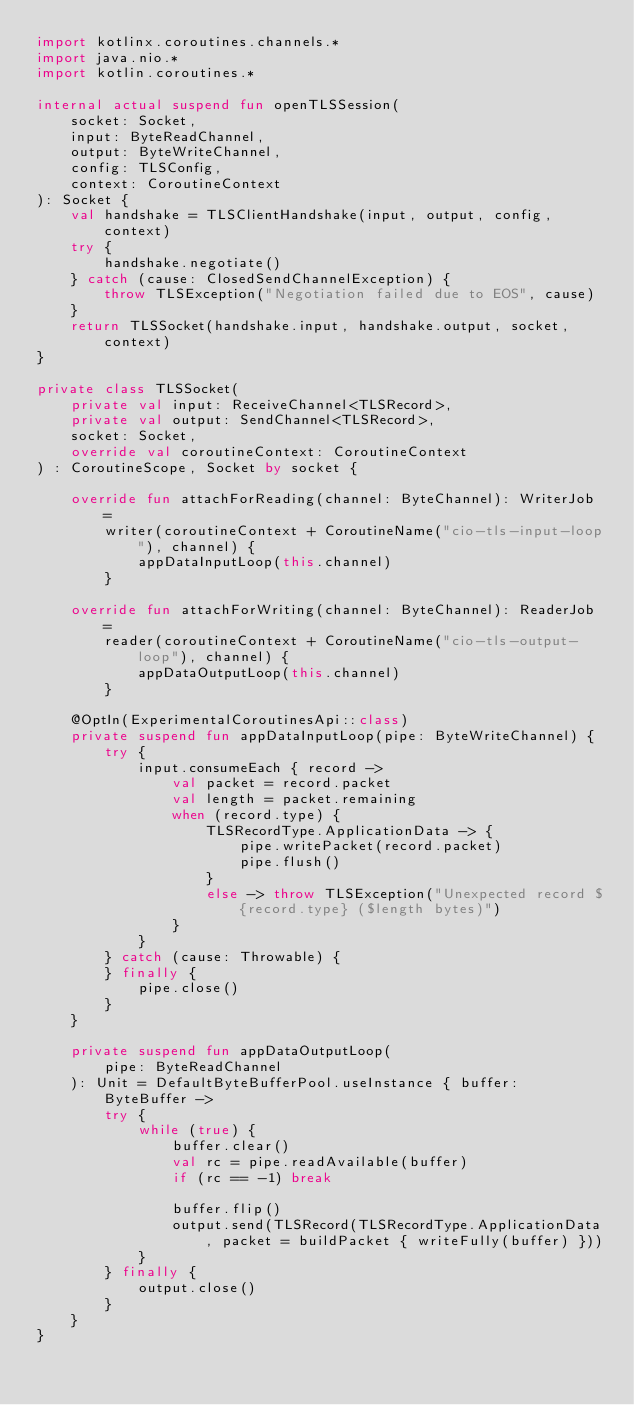<code> <loc_0><loc_0><loc_500><loc_500><_Kotlin_>import kotlinx.coroutines.channels.*
import java.nio.*
import kotlin.coroutines.*

internal actual suspend fun openTLSSession(
    socket: Socket,
    input: ByteReadChannel,
    output: ByteWriteChannel,
    config: TLSConfig,
    context: CoroutineContext
): Socket {
    val handshake = TLSClientHandshake(input, output, config, context)
    try {
        handshake.negotiate()
    } catch (cause: ClosedSendChannelException) {
        throw TLSException("Negotiation failed due to EOS", cause)
    }
    return TLSSocket(handshake.input, handshake.output, socket, context)
}

private class TLSSocket(
    private val input: ReceiveChannel<TLSRecord>,
    private val output: SendChannel<TLSRecord>,
    socket: Socket,
    override val coroutineContext: CoroutineContext
) : CoroutineScope, Socket by socket {

    override fun attachForReading(channel: ByteChannel): WriterJob =
        writer(coroutineContext + CoroutineName("cio-tls-input-loop"), channel) {
            appDataInputLoop(this.channel)
        }

    override fun attachForWriting(channel: ByteChannel): ReaderJob =
        reader(coroutineContext + CoroutineName("cio-tls-output-loop"), channel) {
            appDataOutputLoop(this.channel)
        }

    @OptIn(ExperimentalCoroutinesApi::class)
    private suspend fun appDataInputLoop(pipe: ByteWriteChannel) {
        try {
            input.consumeEach { record ->
                val packet = record.packet
                val length = packet.remaining
                when (record.type) {
                    TLSRecordType.ApplicationData -> {
                        pipe.writePacket(record.packet)
                        pipe.flush()
                    }
                    else -> throw TLSException("Unexpected record ${record.type} ($length bytes)")
                }
            }
        } catch (cause: Throwable) {
        } finally {
            pipe.close()
        }
    }

    private suspend fun appDataOutputLoop(
        pipe: ByteReadChannel
    ): Unit = DefaultByteBufferPool.useInstance { buffer: ByteBuffer ->
        try {
            while (true) {
                buffer.clear()
                val rc = pipe.readAvailable(buffer)
                if (rc == -1) break

                buffer.flip()
                output.send(TLSRecord(TLSRecordType.ApplicationData, packet = buildPacket { writeFully(buffer) }))
            }
        } finally {
            output.close()
        }
    }
}
</code> 